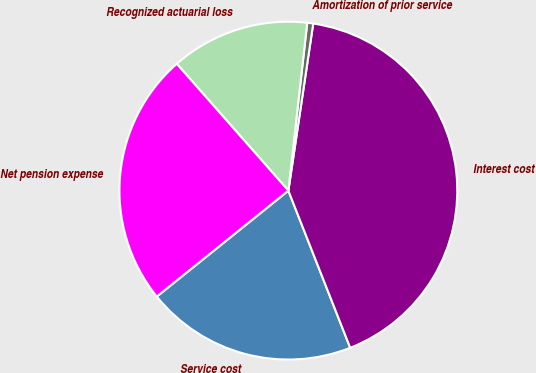Convert chart. <chart><loc_0><loc_0><loc_500><loc_500><pie_chart><fcel>Service cost<fcel>Interest cost<fcel>Amortization of prior service<fcel>Recognized actuarial loss<fcel>Net pension expense<nl><fcel>20.18%<fcel>41.68%<fcel>0.57%<fcel>13.27%<fcel>24.3%<nl></chart> 